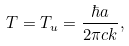Convert formula to latex. <formula><loc_0><loc_0><loc_500><loc_500>T = T _ { u } = \frac { \hbar { a } } { 2 \pi c k } ,</formula> 